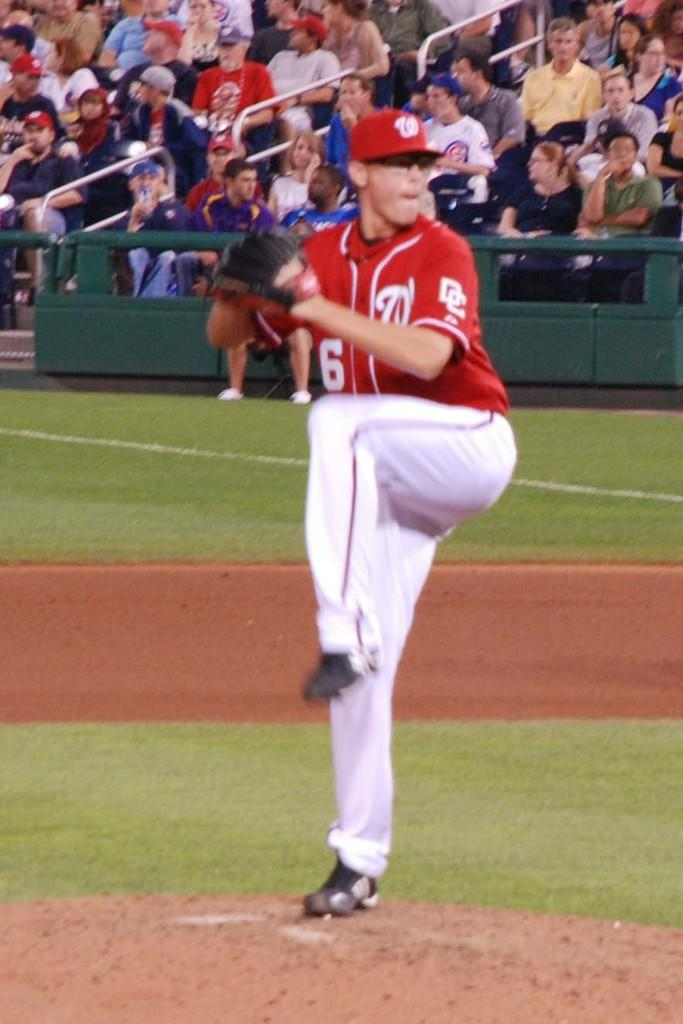<image>
Summarize the visual content of the image. A pitcher wearing a red jersey with the letters DC on the side prepares to throw a pitch 